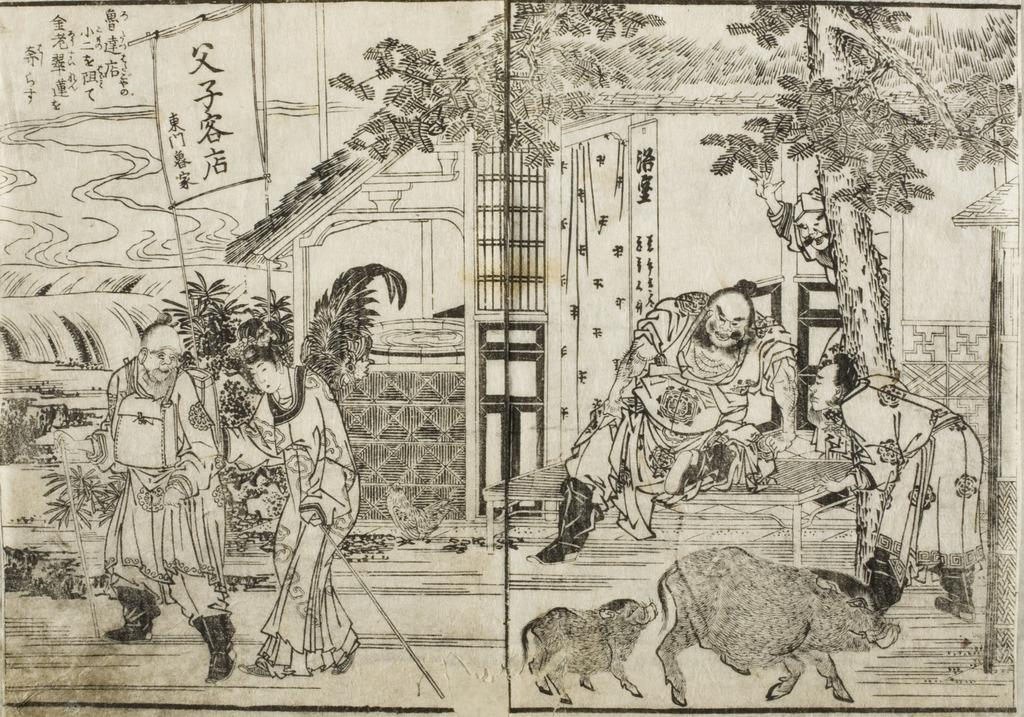What is the main subject of the image? There is an art piece in the image. What elements are included in the art piece? The art piece contains people, animals, trees, plants, a house, and text. Can you describe the setting of the art piece? The art piece depicts a scene that includes people, animals, trees, plants, and a house. How many holes can be seen in the art piece? There are no holes visible in the art piece; it is a two-dimensional representation of a scene. 